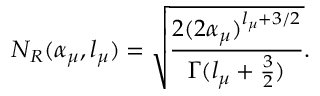Convert formula to latex. <formula><loc_0><loc_0><loc_500><loc_500>N _ { R } ( \alpha _ { \mu } , l _ { \mu } ) = \sqrt { \frac { 2 ( 2 \alpha _ { \mu } ) ^ { l _ { \mu } + 3 / 2 } } { \Gamma ( l _ { \mu } + \frac { 3 } { 2 } ) } } .</formula> 